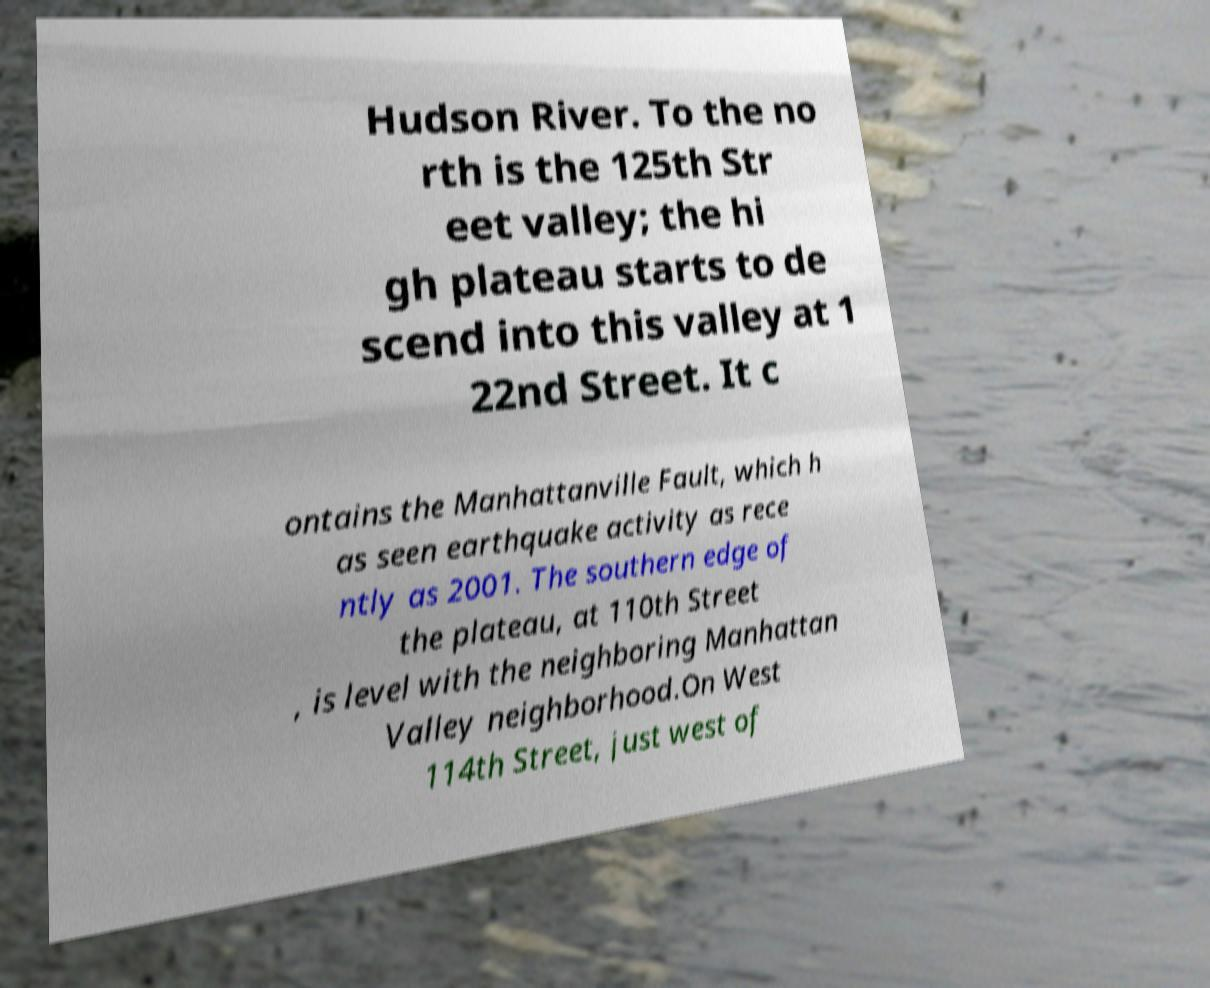What messages or text are displayed in this image? I need them in a readable, typed format. Hudson River. To the no rth is the 125th Str eet valley; the hi gh plateau starts to de scend into this valley at 1 22nd Street. It c ontains the Manhattanville Fault, which h as seen earthquake activity as rece ntly as 2001. The southern edge of the plateau, at 110th Street , is level with the neighboring Manhattan Valley neighborhood.On West 114th Street, just west of 